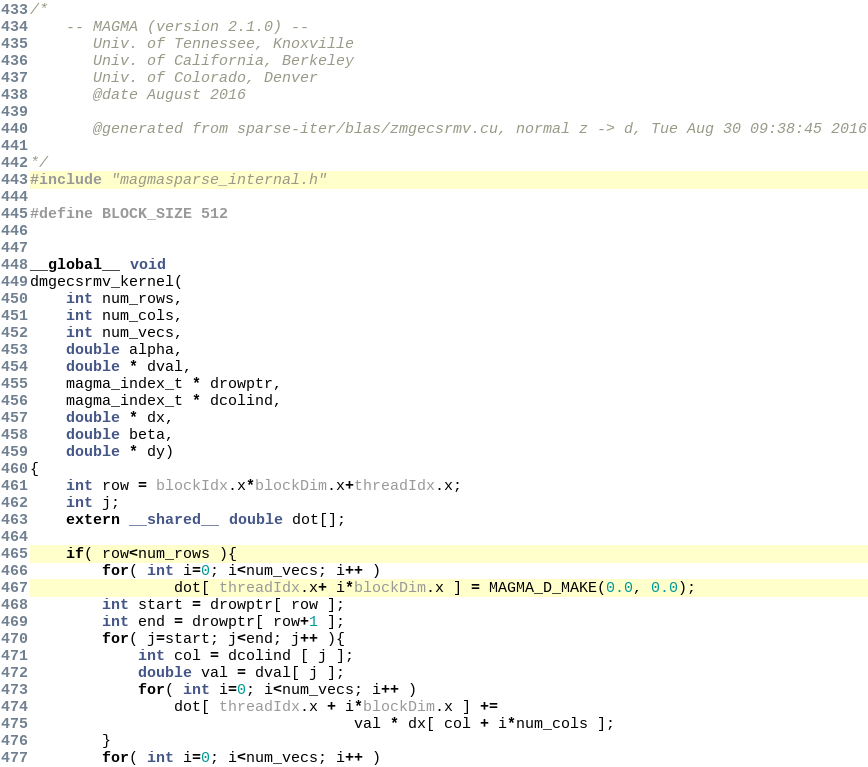Convert code to text. <code><loc_0><loc_0><loc_500><loc_500><_Cuda_>/*
    -- MAGMA (version 2.1.0) --
       Univ. of Tennessee, Knoxville
       Univ. of California, Berkeley
       Univ. of Colorado, Denver
       @date August 2016

       @generated from sparse-iter/blas/zmgecsrmv.cu, normal z -> d, Tue Aug 30 09:38:45 2016

*/
#include "magmasparse_internal.h"

#define BLOCK_SIZE 512


__global__ void 
dmgecsrmv_kernel( 
    int num_rows, 
    int num_cols, 
    int num_vecs,
    double alpha, 
    double * dval, 
    magma_index_t * drowptr, 
    magma_index_t * dcolind,
    double * dx,
    double beta, 
    double * dy)
{
    int row = blockIdx.x*blockDim.x+threadIdx.x;
    int j;
    extern __shared__ double dot[];

    if( row<num_rows ){
        for( int i=0; i<num_vecs; i++ )
                dot[ threadIdx.x+ i*blockDim.x ] = MAGMA_D_MAKE(0.0, 0.0);
        int start = drowptr[ row ];
        int end = drowptr[ row+1 ];
        for( j=start; j<end; j++ ){
            int col = dcolind [ j ];
            double val = dval[ j ];
            for( int i=0; i<num_vecs; i++ )
                dot[ threadIdx.x + i*blockDim.x ] += 
                                    val * dx[ col + i*num_cols ];
        }
        for( int i=0; i<num_vecs; i++ )</code> 